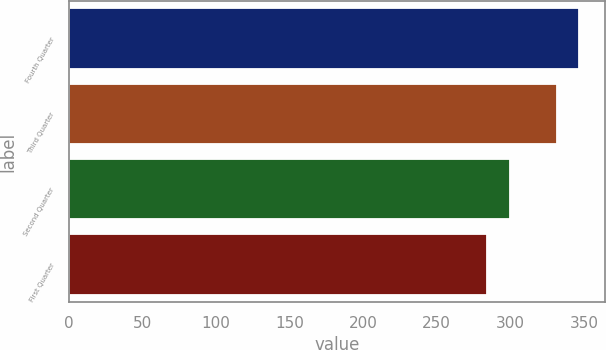Convert chart. <chart><loc_0><loc_0><loc_500><loc_500><bar_chart><fcel>Fourth Quarter<fcel>Third Quarter<fcel>Second Quarter<fcel>First Quarter<nl><fcel>347<fcel>332<fcel>300<fcel>284.2<nl></chart> 